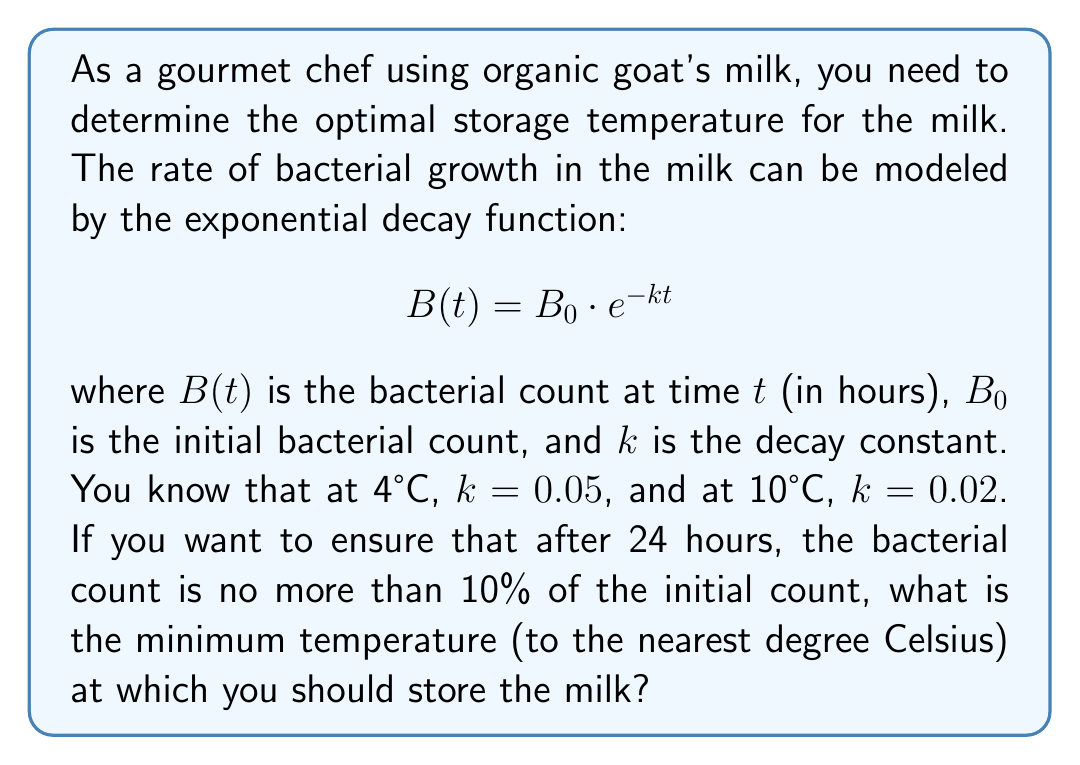What is the answer to this math problem? To solve this problem, we need to follow these steps:

1) We want $B(24)$ to be 10% of $B_0$, so we can write:

   $$\frac{B(24)}{B_0} = 0.1$$

2) Substituting this into our exponential decay function:

   $$\frac{B_0 \cdot e^{-k \cdot 24}}{B_0} = 0.1$$

3) The $B_0$ terms cancel out:

   $$e^{-k \cdot 24} = 0.1$$

4) Taking the natural log of both sides:

   $$-k \cdot 24 = \ln(0.1)$$

5) Solving for $k$:

   $$k = -\frac{\ln(0.1)}{24} \approx 0.0959$$

6) Now we need to find the temperature that corresponds to this $k$ value. We can use linear interpolation between the known points:

   At 4°C, $k = 0.05$
   At 10°C, $k = 0.02$

7) We can set up a proportion:

   $$\frac{10 - 4}{0.02 - 0.05} = \frac{T - 4}{0.0959 - 0.05}$$

   where $T$ is the temperature we're looking for.

8) Solving this equation:

   $$\frac{6}{-0.03} = \frac{T - 4}{0.0459}$$
   $$6 \cdot 0.0459 = -0.03 \cdot (T - 4)$$
   $$0.2754 = -0.03T + 0.12$$
   $$0.1554 = -0.03T$$
   $$T = -5.18$$

9) Therefore, the temperature should be approximately -5°C. However, since milk freezes at about 0°C, the minimum practical temperature is 0°C.
Answer: 0°C 